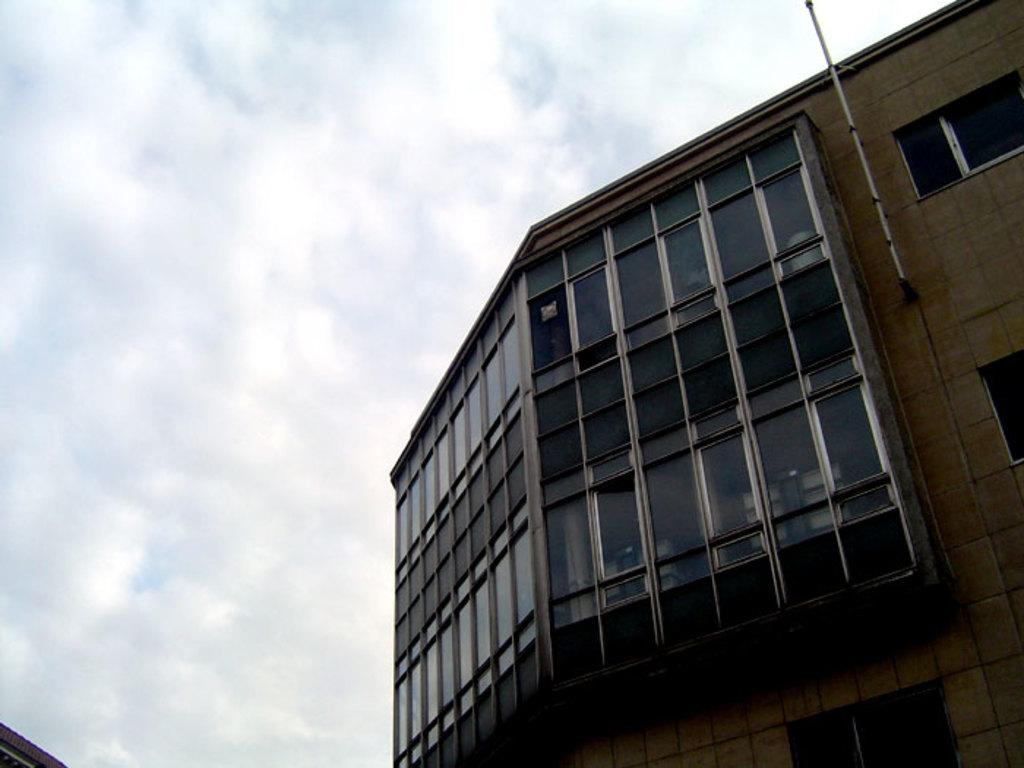What structure is located on the right side of the image? There is a building on the right side of the image. What is visible at the top of the image? The sky is visible at the top of the image. How would you describe the sky in the image? The sky appears to be cloudy. How many birds are sitting on the ball in the image? There is no ball or birds present in the image. What is the building's desire in the image? Buildings do not have desires, as they are inanimate objects. 